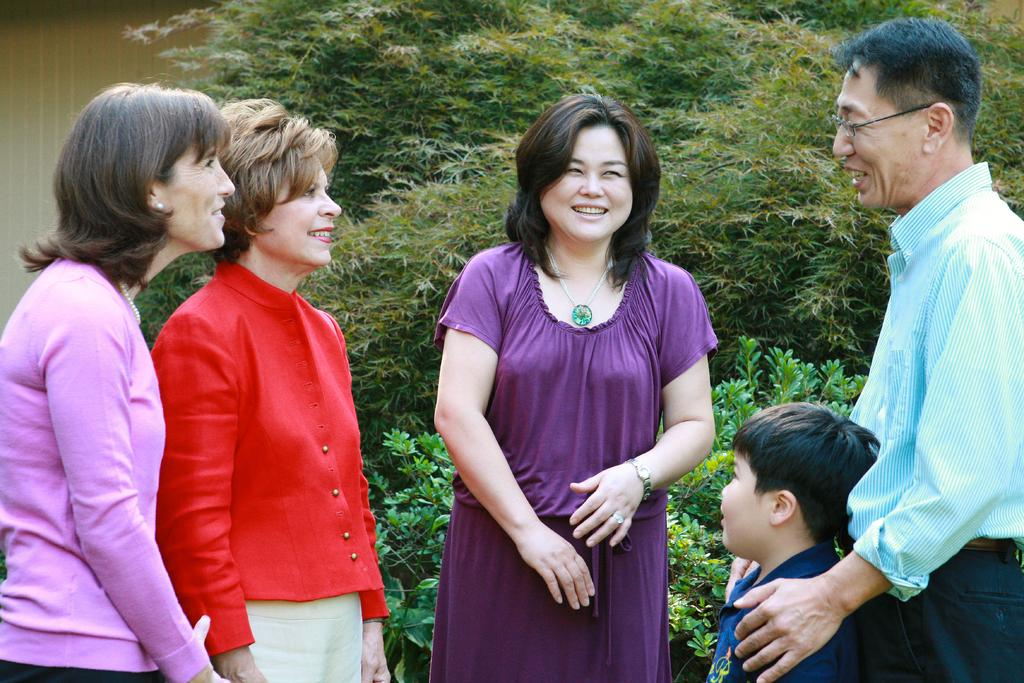What are the people in the image doing? The people in the image are standing and smiling. What can be seen in the background of the image? There are plants visible in the background of the image. What is on the left side of the image? There is a wall on the left side of the image. What channel is the wall on the left side of the image tuned to? The wall is not a television or device that can be tuned to a channel; it is a physical structure in the image. 